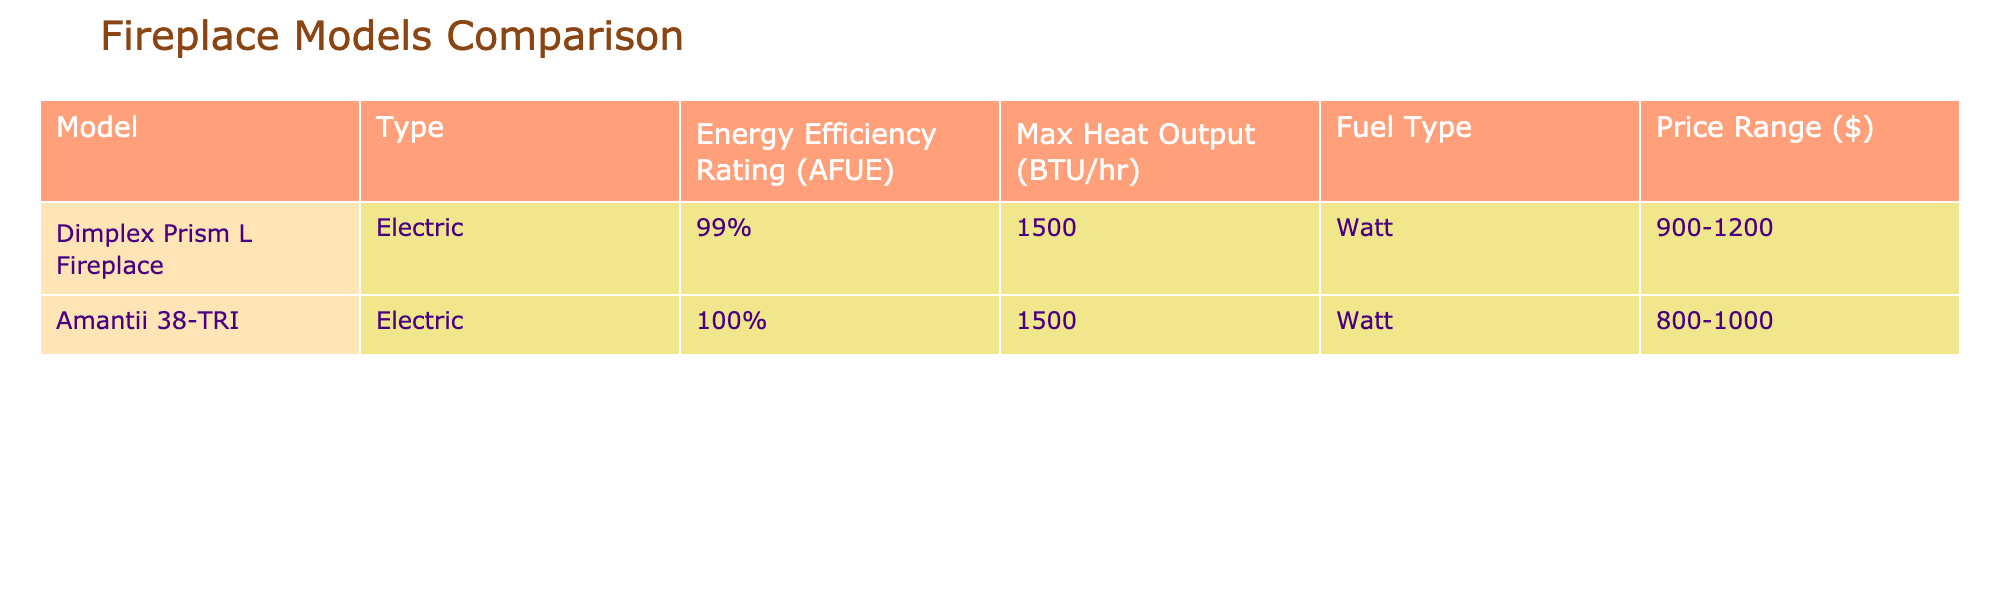What is the energy efficiency rating of the Amantii 38-TRI model? The energy efficiency rating for the Amantii 38-TRI model is found in the table under the corresponding column, which indicates it is 100%.
Answer: 100% Which fireplace model has the highest maximum heat output? The maximum heat output for each model is shown in the table, and since both models produce 1500 BTU/hr, neither has a higher output.
Answer: Both models are equal Is the Dimplex Prism L Fireplace more affordable than the Amantii 38-TRI? The price ranges for both models can be compared from the table. The Dimplex Prism L Fireplace is listed at 900-1200 dollars, while the Amantii 38-TRI ranges from 800-1000 dollars, indicating the Amantii is typically less expensive.
Answer: Yes What is the total price range for both fireplace models combined? To find the total price range, we look at the price ranges for both models: Dimplex is 900-1200 dollars and Amantii is 800-1000 dollars. The lowest combined price range is the lowest from each model (800), and the highest combined price is the highest from each model (1200), giving us 800-1200 dollars.
Answer: 800-1200 dollars Is the fuel type for both fireplace models the same? By checking the fuel type column in the table, we see that both models use electricity (Watt), confirming they have the same fuel type.
Answer: Yes What is the average energy efficiency rating of both models? The energy efficiency ratings are expressed as percentages: 99% for the Dimplex Prism L Fireplace and 100% for the Amantii 38-TRI. To calculate the average, we add these values (99 + 100 = 199) and then divide by 2, resulting in an average efficiency of 99.5%.
Answer: 99.5% Does the higher price correlate with a higher energy efficiency rating in this table? In the table, the higher-priced model, the Dimplex Prism L Fireplace (900-1200 dollars), has a slightly lower efficiency rating (99%) than the Amantii 38-TRI at a lower price (800-1000 dollars) with an efficiency of 100%. Thus, in this case, there is no direct correlation as the cheaper model is more efficient.
Answer: No What is the difference in maximum heat output (BTU/hr) between the two models? Both models have the same maximum heat output of 1500 BTU/hr. Hence, the difference between them is calculated as (1500 - 1500), which equals 0.
Answer: 0 BTU/hr 